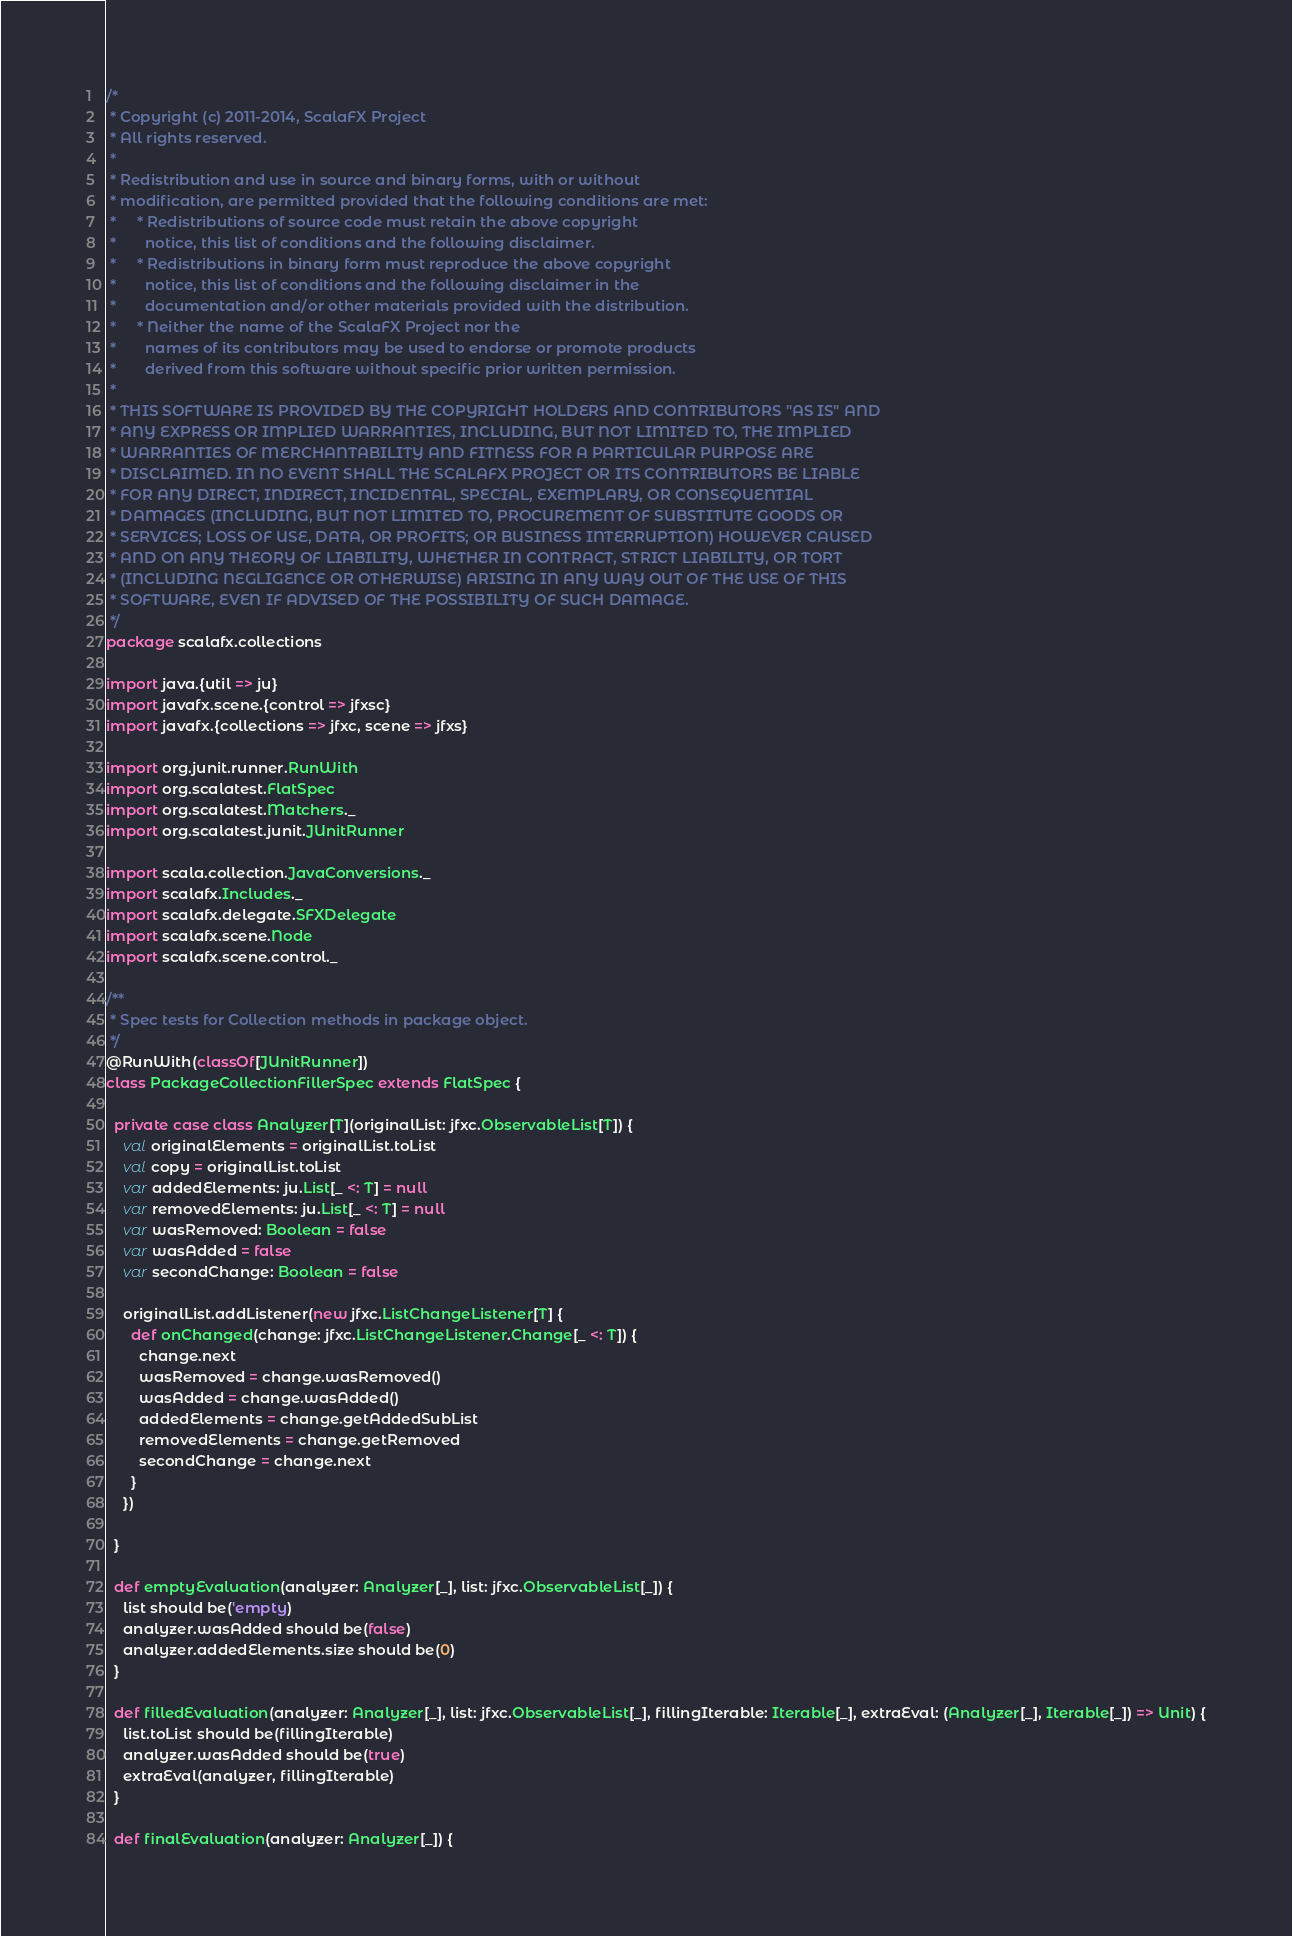Convert code to text. <code><loc_0><loc_0><loc_500><loc_500><_Scala_>/*
 * Copyright (c) 2011-2014, ScalaFX Project
 * All rights reserved.
 *
 * Redistribution and use in source and binary forms, with or without
 * modification, are permitted provided that the following conditions are met:
 *     * Redistributions of source code must retain the above copyright
 *       notice, this list of conditions and the following disclaimer.
 *     * Redistributions in binary form must reproduce the above copyright
 *       notice, this list of conditions and the following disclaimer in the
 *       documentation and/or other materials provided with the distribution.
 *     * Neither the name of the ScalaFX Project nor the
 *       names of its contributors may be used to endorse or promote products
 *       derived from this software without specific prior written permission.
 *
 * THIS SOFTWARE IS PROVIDED BY THE COPYRIGHT HOLDERS AND CONTRIBUTORS "AS IS" AND
 * ANY EXPRESS OR IMPLIED WARRANTIES, INCLUDING, BUT NOT LIMITED TO, THE IMPLIED
 * WARRANTIES OF MERCHANTABILITY AND FITNESS FOR A PARTICULAR PURPOSE ARE
 * DISCLAIMED. IN NO EVENT SHALL THE SCALAFX PROJECT OR ITS CONTRIBUTORS BE LIABLE
 * FOR ANY DIRECT, INDIRECT, INCIDENTAL, SPECIAL, EXEMPLARY, OR CONSEQUENTIAL
 * DAMAGES (INCLUDING, BUT NOT LIMITED TO, PROCUREMENT OF SUBSTITUTE GOODS OR
 * SERVICES; LOSS OF USE, DATA, OR PROFITS; OR BUSINESS INTERRUPTION) HOWEVER CAUSED
 * AND ON ANY THEORY OF LIABILITY, WHETHER IN CONTRACT, STRICT LIABILITY, OR TORT
 * (INCLUDING NEGLIGENCE OR OTHERWISE) ARISING IN ANY WAY OUT OF THE USE OF THIS
 * SOFTWARE, EVEN IF ADVISED OF THE POSSIBILITY OF SUCH DAMAGE.
 */
package scalafx.collections

import java.{util => ju}
import javafx.scene.{control => jfxsc}
import javafx.{collections => jfxc, scene => jfxs}

import org.junit.runner.RunWith
import org.scalatest.FlatSpec
import org.scalatest.Matchers._
import org.scalatest.junit.JUnitRunner

import scala.collection.JavaConversions._
import scalafx.Includes._
import scalafx.delegate.SFXDelegate
import scalafx.scene.Node
import scalafx.scene.control._

/**
 * Spec tests for Collection methods in package object.
 */
@RunWith(classOf[JUnitRunner])
class PackageCollectionFillerSpec extends FlatSpec {

  private case class Analyzer[T](originalList: jfxc.ObservableList[T]) {
    val originalElements = originalList.toList
    val copy = originalList.toList
    var addedElements: ju.List[_ <: T] = null
    var removedElements: ju.List[_ <: T] = null
    var wasRemoved: Boolean = false
    var wasAdded = false
    var secondChange: Boolean = false

    originalList.addListener(new jfxc.ListChangeListener[T] {
      def onChanged(change: jfxc.ListChangeListener.Change[_ <: T]) {
        change.next
        wasRemoved = change.wasRemoved()
        wasAdded = change.wasAdded()
        addedElements = change.getAddedSubList
        removedElements = change.getRemoved
        secondChange = change.next
      }
    })

  }

  def emptyEvaluation(analyzer: Analyzer[_], list: jfxc.ObservableList[_]) {
    list should be('empty)
    analyzer.wasAdded should be(false)
    analyzer.addedElements.size should be(0)
  }

  def filledEvaluation(analyzer: Analyzer[_], list: jfxc.ObservableList[_], fillingIterable: Iterable[_], extraEval: (Analyzer[_], Iterable[_]) => Unit) {
    list.toList should be(fillingIterable)
    analyzer.wasAdded should be(true)
    extraEval(analyzer, fillingIterable)
  }

  def finalEvaluation(analyzer: Analyzer[_]) {</code> 